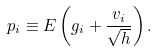<formula> <loc_0><loc_0><loc_500><loc_500>p _ { i } \equiv E \left ( { g _ { i } + \frac { { v _ { i } } } { \sqrt { h } } } \right ) .</formula> 